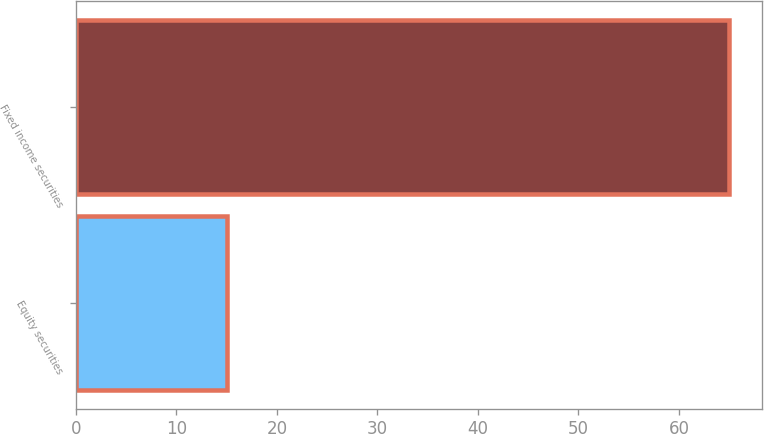<chart> <loc_0><loc_0><loc_500><loc_500><bar_chart><fcel>Equity securities<fcel>Fixed income securities<nl><fcel>15<fcel>65<nl></chart> 